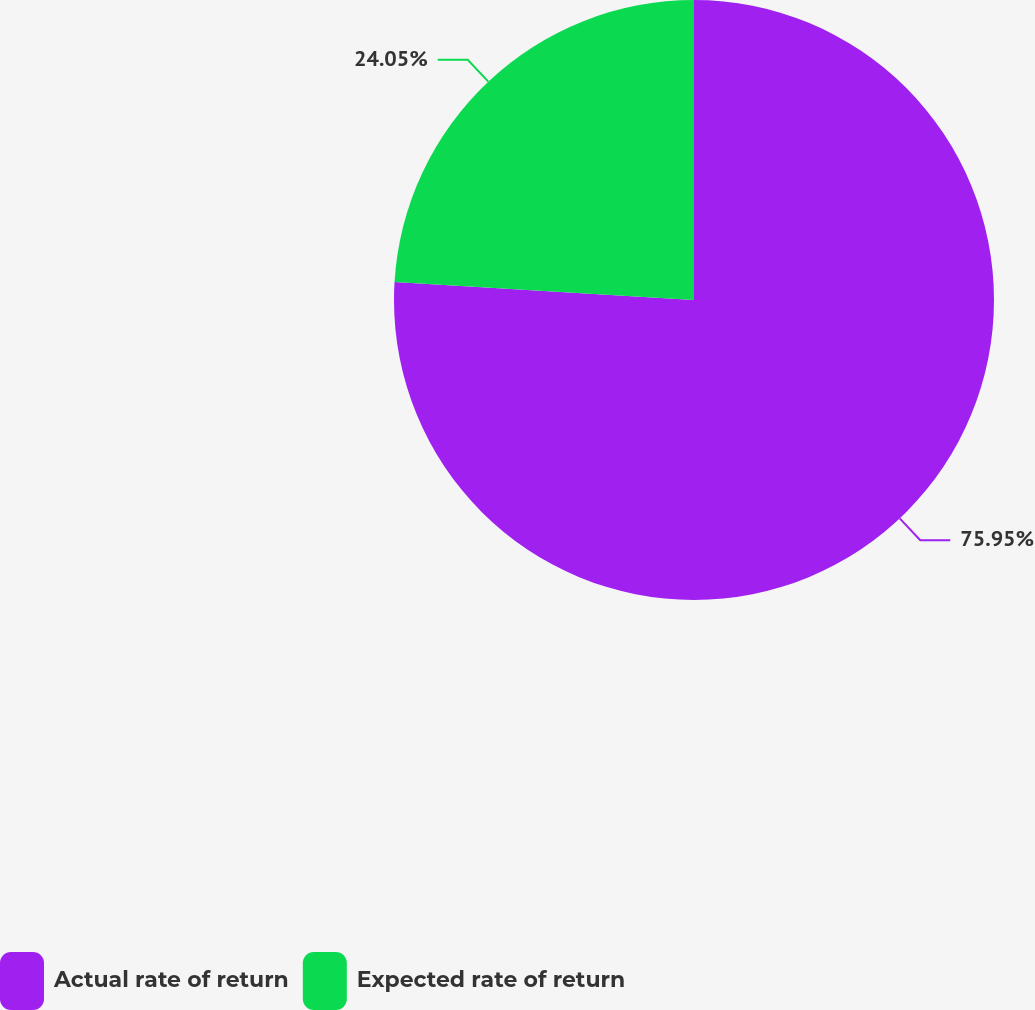Convert chart. <chart><loc_0><loc_0><loc_500><loc_500><pie_chart><fcel>Actual rate of return<fcel>Expected rate of return<nl><fcel>75.95%<fcel>24.05%<nl></chart> 